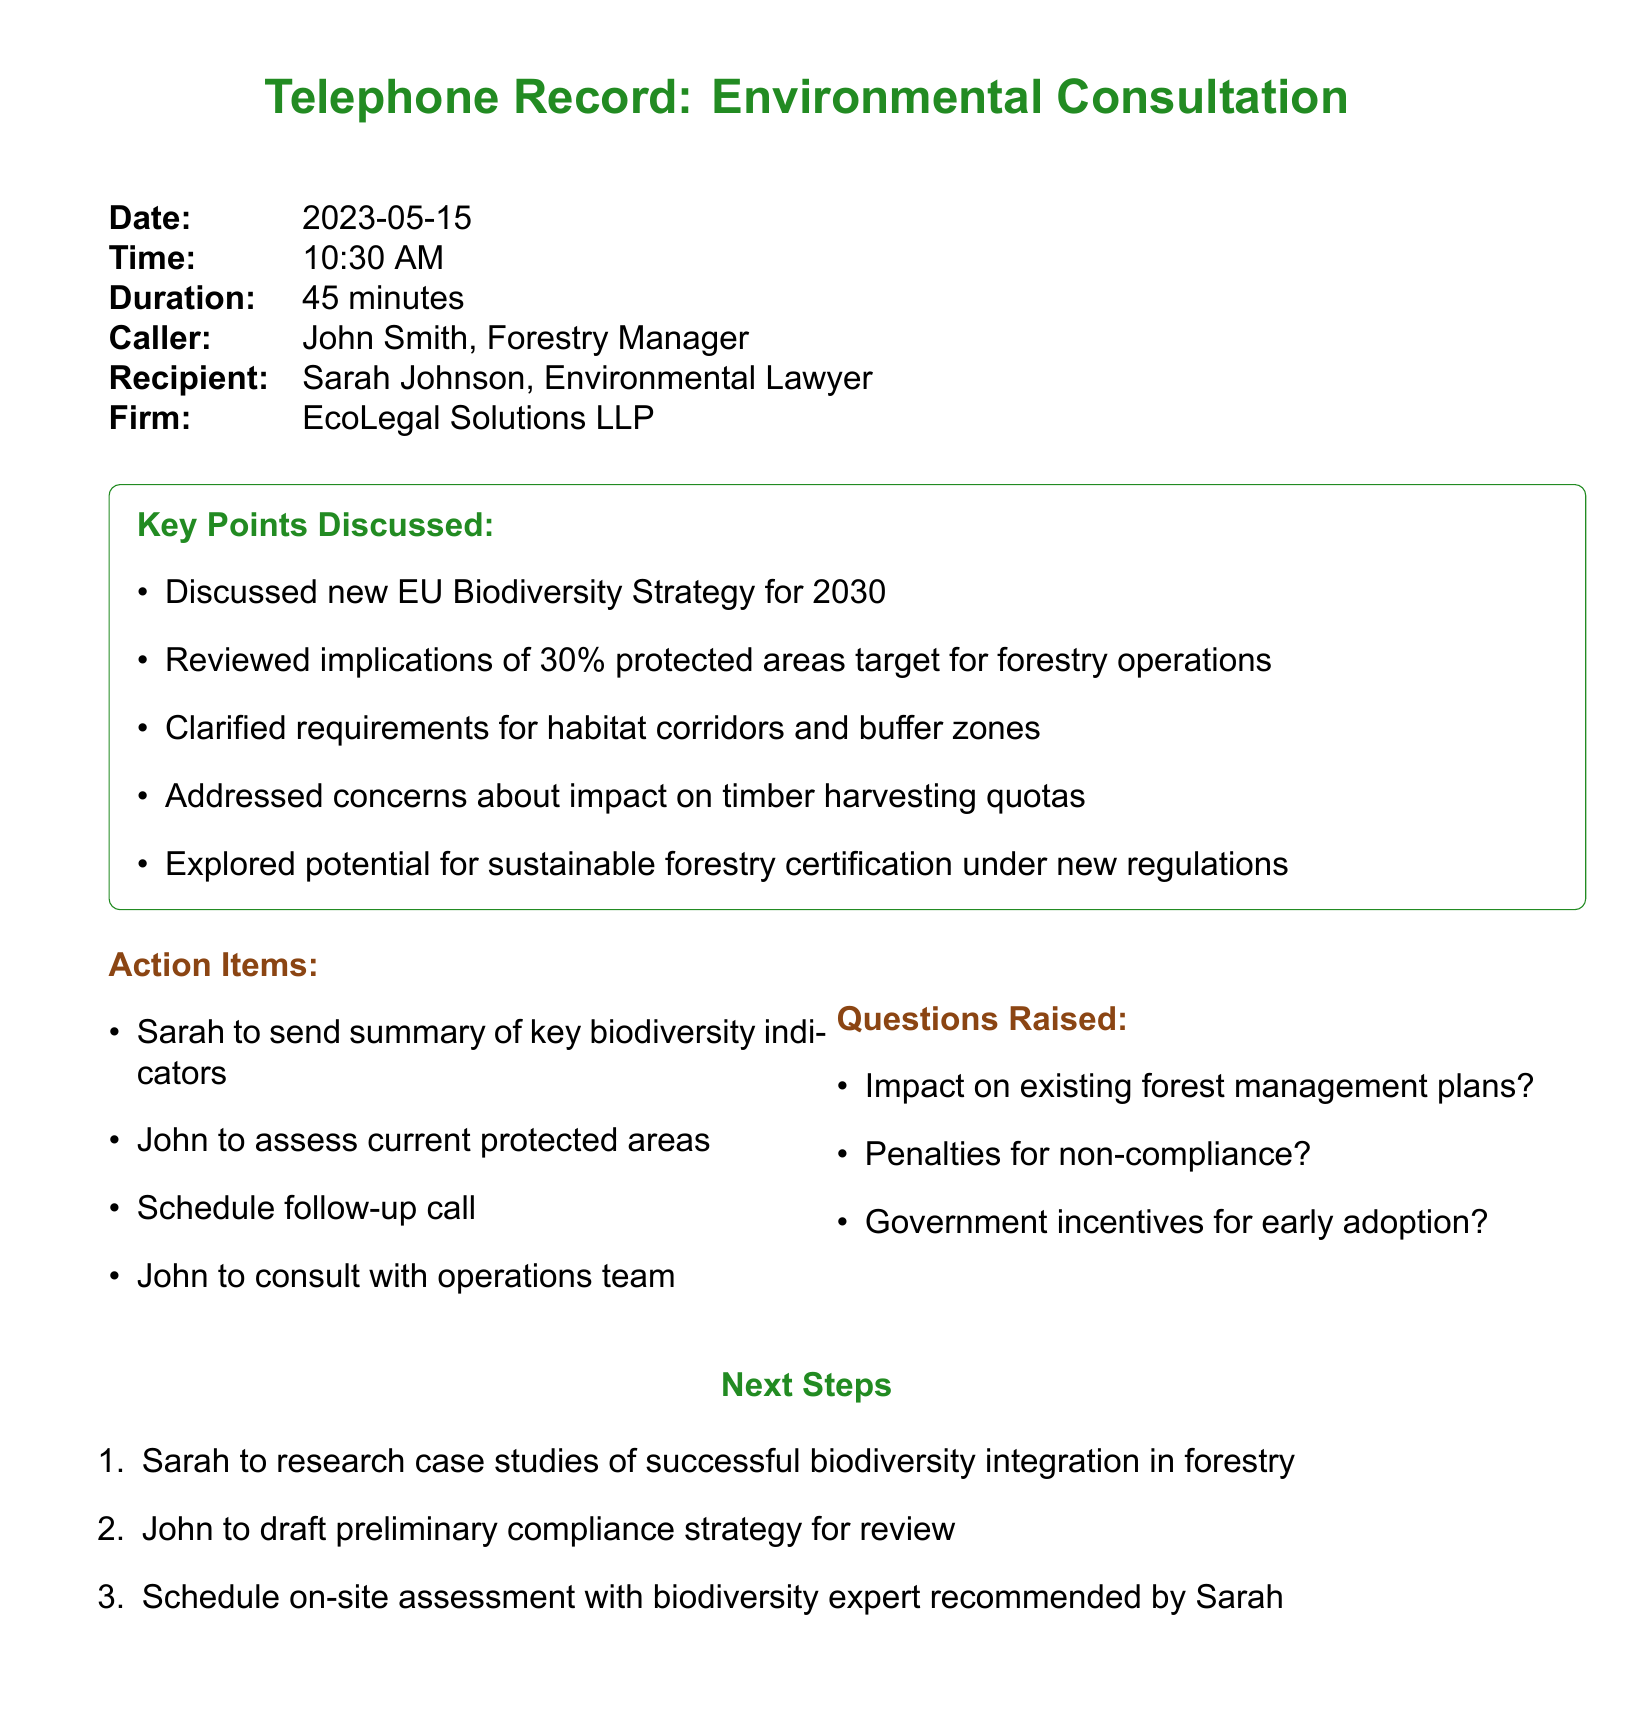What is the date of the telephone consultation? The date of the consultation is stated in the document header.
Answer: 2023-05-15 Who is the caller in the telephone record? The caller is identified at the top of the document.
Answer: John Smith What is the main topic of the discussion? The discussion mainly revolves around the new EU Biodiversity Strategy for 2030, as outlined in the key points.
Answer: New EU Biodiversity Strategy for 2030 What percentage of protected areas is targeted under the new regulations? The specific percentage is mentioned in the key points section of the document.
Answer: 30% What were the action items for John? The action items outlined in the document specify what John will do following the call.
Answer: Assess current protected areas What are the concerns regarding timber harvesting? The document notes that there are concerns specifically regarding timber harvesting quotas.
Answer: Impact on timber harvesting quotas What are the penalties mentioned for non-compliance? The document includes a question about penalties, indicating this as a concern.
Answer: Penalties for non-compliance? What is one of the next steps discussed? The next steps are listed in a separate section, detailing actions to take after the call.
Answer: Research case studies of successful biodiversity integration in forestry Who is the recipient of the call? The recipient's name is stated clearly at the beginning of the document.
Answer: Sarah Johnson 